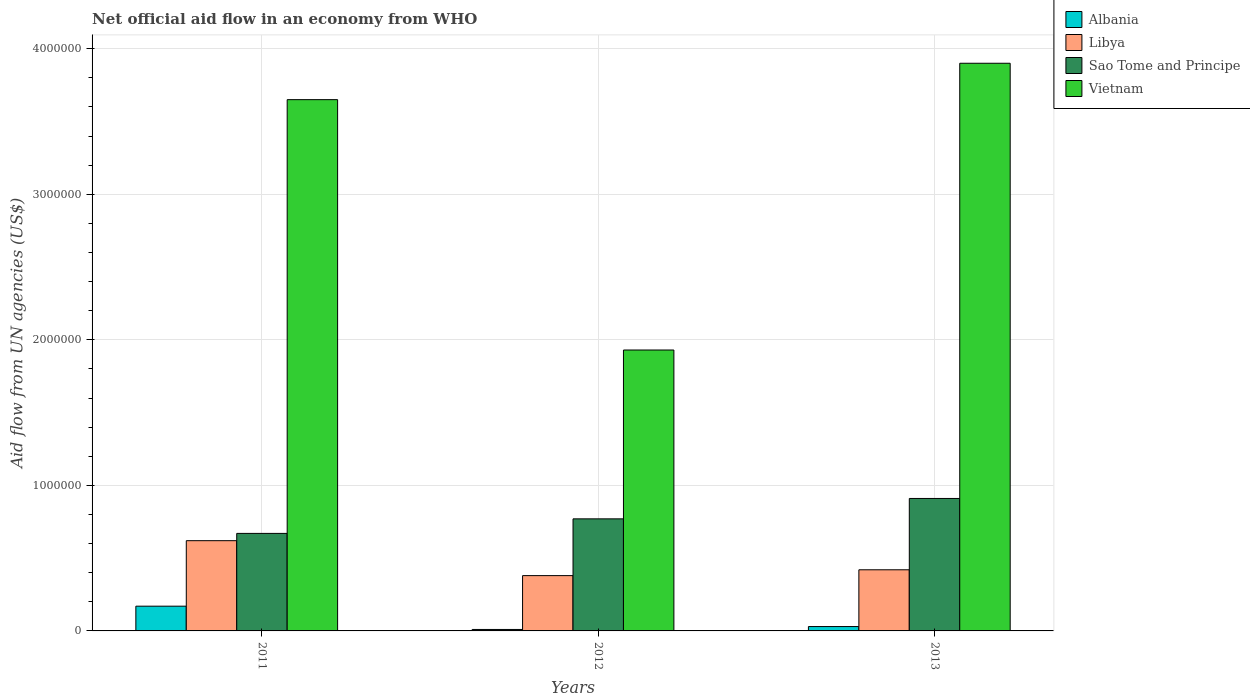Are the number of bars per tick equal to the number of legend labels?
Offer a very short reply. Yes. Are the number of bars on each tick of the X-axis equal?
Provide a succinct answer. Yes. What is the label of the 3rd group of bars from the left?
Offer a very short reply. 2013. In how many cases, is the number of bars for a given year not equal to the number of legend labels?
Offer a terse response. 0. Across all years, what is the maximum net official aid flow in Vietnam?
Make the answer very short. 3.90e+06. Across all years, what is the minimum net official aid flow in Sao Tome and Principe?
Ensure brevity in your answer.  6.70e+05. What is the total net official aid flow in Vietnam in the graph?
Offer a very short reply. 9.48e+06. What is the difference between the net official aid flow in Albania in 2012 and the net official aid flow in Sao Tome and Principe in 2013?
Provide a succinct answer. -9.00e+05. What is the average net official aid flow in Vietnam per year?
Give a very brief answer. 3.16e+06. In the year 2011, what is the difference between the net official aid flow in Albania and net official aid flow in Sao Tome and Principe?
Provide a short and direct response. -5.00e+05. In how many years, is the net official aid flow in Libya greater than 3800000 US$?
Give a very brief answer. 0. What is the ratio of the net official aid flow in Sao Tome and Principe in 2011 to that in 2013?
Ensure brevity in your answer.  0.74. Is the difference between the net official aid flow in Albania in 2011 and 2013 greater than the difference between the net official aid flow in Sao Tome and Principe in 2011 and 2013?
Give a very brief answer. Yes. What is the difference between the highest and the second highest net official aid flow in Albania?
Your answer should be compact. 1.40e+05. What is the difference between the highest and the lowest net official aid flow in Libya?
Offer a very short reply. 2.40e+05. Is the sum of the net official aid flow in Libya in 2011 and 2013 greater than the maximum net official aid flow in Sao Tome and Principe across all years?
Your answer should be compact. Yes. Is it the case that in every year, the sum of the net official aid flow in Vietnam and net official aid flow in Libya is greater than the sum of net official aid flow in Albania and net official aid flow in Sao Tome and Principe?
Your response must be concise. Yes. What does the 3rd bar from the left in 2012 represents?
Provide a succinct answer. Sao Tome and Principe. What does the 1st bar from the right in 2011 represents?
Keep it short and to the point. Vietnam. Is it the case that in every year, the sum of the net official aid flow in Albania and net official aid flow in Sao Tome and Principe is greater than the net official aid flow in Vietnam?
Provide a succinct answer. No. How many bars are there?
Your answer should be very brief. 12. How many years are there in the graph?
Ensure brevity in your answer.  3. Are the values on the major ticks of Y-axis written in scientific E-notation?
Keep it short and to the point. No. Does the graph contain any zero values?
Offer a terse response. No. How many legend labels are there?
Offer a very short reply. 4. What is the title of the graph?
Provide a short and direct response. Net official aid flow in an economy from WHO. What is the label or title of the X-axis?
Provide a succinct answer. Years. What is the label or title of the Y-axis?
Provide a succinct answer. Aid flow from UN agencies (US$). What is the Aid flow from UN agencies (US$) of Libya in 2011?
Your response must be concise. 6.20e+05. What is the Aid flow from UN agencies (US$) in Sao Tome and Principe in 2011?
Ensure brevity in your answer.  6.70e+05. What is the Aid flow from UN agencies (US$) in Vietnam in 2011?
Keep it short and to the point. 3.65e+06. What is the Aid flow from UN agencies (US$) in Albania in 2012?
Keep it short and to the point. 10000. What is the Aid flow from UN agencies (US$) in Sao Tome and Principe in 2012?
Your response must be concise. 7.70e+05. What is the Aid flow from UN agencies (US$) of Vietnam in 2012?
Give a very brief answer. 1.93e+06. What is the Aid flow from UN agencies (US$) of Albania in 2013?
Give a very brief answer. 3.00e+04. What is the Aid flow from UN agencies (US$) in Sao Tome and Principe in 2013?
Give a very brief answer. 9.10e+05. What is the Aid flow from UN agencies (US$) of Vietnam in 2013?
Provide a succinct answer. 3.90e+06. Across all years, what is the maximum Aid flow from UN agencies (US$) in Libya?
Your answer should be very brief. 6.20e+05. Across all years, what is the maximum Aid flow from UN agencies (US$) in Sao Tome and Principe?
Provide a succinct answer. 9.10e+05. Across all years, what is the maximum Aid flow from UN agencies (US$) of Vietnam?
Make the answer very short. 3.90e+06. Across all years, what is the minimum Aid flow from UN agencies (US$) in Libya?
Keep it short and to the point. 3.80e+05. Across all years, what is the minimum Aid flow from UN agencies (US$) in Sao Tome and Principe?
Provide a short and direct response. 6.70e+05. Across all years, what is the minimum Aid flow from UN agencies (US$) in Vietnam?
Your response must be concise. 1.93e+06. What is the total Aid flow from UN agencies (US$) of Libya in the graph?
Give a very brief answer. 1.42e+06. What is the total Aid flow from UN agencies (US$) of Sao Tome and Principe in the graph?
Your response must be concise. 2.35e+06. What is the total Aid flow from UN agencies (US$) in Vietnam in the graph?
Offer a terse response. 9.48e+06. What is the difference between the Aid flow from UN agencies (US$) in Vietnam in 2011 and that in 2012?
Ensure brevity in your answer.  1.72e+06. What is the difference between the Aid flow from UN agencies (US$) of Libya in 2011 and that in 2013?
Ensure brevity in your answer.  2.00e+05. What is the difference between the Aid flow from UN agencies (US$) of Vietnam in 2011 and that in 2013?
Give a very brief answer. -2.50e+05. What is the difference between the Aid flow from UN agencies (US$) in Vietnam in 2012 and that in 2013?
Your answer should be compact. -1.97e+06. What is the difference between the Aid flow from UN agencies (US$) of Albania in 2011 and the Aid flow from UN agencies (US$) of Libya in 2012?
Ensure brevity in your answer.  -2.10e+05. What is the difference between the Aid flow from UN agencies (US$) in Albania in 2011 and the Aid flow from UN agencies (US$) in Sao Tome and Principe in 2012?
Provide a short and direct response. -6.00e+05. What is the difference between the Aid flow from UN agencies (US$) in Albania in 2011 and the Aid flow from UN agencies (US$) in Vietnam in 2012?
Ensure brevity in your answer.  -1.76e+06. What is the difference between the Aid flow from UN agencies (US$) of Libya in 2011 and the Aid flow from UN agencies (US$) of Vietnam in 2012?
Offer a very short reply. -1.31e+06. What is the difference between the Aid flow from UN agencies (US$) in Sao Tome and Principe in 2011 and the Aid flow from UN agencies (US$) in Vietnam in 2012?
Provide a short and direct response. -1.26e+06. What is the difference between the Aid flow from UN agencies (US$) of Albania in 2011 and the Aid flow from UN agencies (US$) of Sao Tome and Principe in 2013?
Provide a short and direct response. -7.40e+05. What is the difference between the Aid flow from UN agencies (US$) of Albania in 2011 and the Aid flow from UN agencies (US$) of Vietnam in 2013?
Ensure brevity in your answer.  -3.73e+06. What is the difference between the Aid flow from UN agencies (US$) in Libya in 2011 and the Aid flow from UN agencies (US$) in Sao Tome and Principe in 2013?
Offer a terse response. -2.90e+05. What is the difference between the Aid flow from UN agencies (US$) in Libya in 2011 and the Aid flow from UN agencies (US$) in Vietnam in 2013?
Your answer should be compact. -3.28e+06. What is the difference between the Aid flow from UN agencies (US$) in Sao Tome and Principe in 2011 and the Aid flow from UN agencies (US$) in Vietnam in 2013?
Your answer should be compact. -3.23e+06. What is the difference between the Aid flow from UN agencies (US$) of Albania in 2012 and the Aid flow from UN agencies (US$) of Libya in 2013?
Give a very brief answer. -4.10e+05. What is the difference between the Aid flow from UN agencies (US$) of Albania in 2012 and the Aid flow from UN agencies (US$) of Sao Tome and Principe in 2013?
Offer a very short reply. -9.00e+05. What is the difference between the Aid flow from UN agencies (US$) of Albania in 2012 and the Aid flow from UN agencies (US$) of Vietnam in 2013?
Make the answer very short. -3.89e+06. What is the difference between the Aid flow from UN agencies (US$) of Libya in 2012 and the Aid flow from UN agencies (US$) of Sao Tome and Principe in 2013?
Provide a short and direct response. -5.30e+05. What is the difference between the Aid flow from UN agencies (US$) of Libya in 2012 and the Aid flow from UN agencies (US$) of Vietnam in 2013?
Provide a succinct answer. -3.52e+06. What is the difference between the Aid flow from UN agencies (US$) of Sao Tome and Principe in 2012 and the Aid flow from UN agencies (US$) of Vietnam in 2013?
Your answer should be very brief. -3.13e+06. What is the average Aid flow from UN agencies (US$) of Albania per year?
Provide a short and direct response. 7.00e+04. What is the average Aid flow from UN agencies (US$) in Libya per year?
Your answer should be compact. 4.73e+05. What is the average Aid flow from UN agencies (US$) in Sao Tome and Principe per year?
Your answer should be very brief. 7.83e+05. What is the average Aid flow from UN agencies (US$) of Vietnam per year?
Offer a very short reply. 3.16e+06. In the year 2011, what is the difference between the Aid flow from UN agencies (US$) of Albania and Aid flow from UN agencies (US$) of Libya?
Your response must be concise. -4.50e+05. In the year 2011, what is the difference between the Aid flow from UN agencies (US$) of Albania and Aid flow from UN agencies (US$) of Sao Tome and Principe?
Your response must be concise. -5.00e+05. In the year 2011, what is the difference between the Aid flow from UN agencies (US$) of Albania and Aid flow from UN agencies (US$) of Vietnam?
Provide a succinct answer. -3.48e+06. In the year 2011, what is the difference between the Aid flow from UN agencies (US$) in Libya and Aid flow from UN agencies (US$) in Vietnam?
Give a very brief answer. -3.03e+06. In the year 2011, what is the difference between the Aid flow from UN agencies (US$) of Sao Tome and Principe and Aid flow from UN agencies (US$) of Vietnam?
Provide a succinct answer. -2.98e+06. In the year 2012, what is the difference between the Aid flow from UN agencies (US$) in Albania and Aid flow from UN agencies (US$) in Libya?
Make the answer very short. -3.70e+05. In the year 2012, what is the difference between the Aid flow from UN agencies (US$) in Albania and Aid flow from UN agencies (US$) in Sao Tome and Principe?
Your response must be concise. -7.60e+05. In the year 2012, what is the difference between the Aid flow from UN agencies (US$) of Albania and Aid flow from UN agencies (US$) of Vietnam?
Give a very brief answer. -1.92e+06. In the year 2012, what is the difference between the Aid flow from UN agencies (US$) in Libya and Aid flow from UN agencies (US$) in Sao Tome and Principe?
Ensure brevity in your answer.  -3.90e+05. In the year 2012, what is the difference between the Aid flow from UN agencies (US$) of Libya and Aid flow from UN agencies (US$) of Vietnam?
Offer a very short reply. -1.55e+06. In the year 2012, what is the difference between the Aid flow from UN agencies (US$) in Sao Tome and Principe and Aid flow from UN agencies (US$) in Vietnam?
Provide a short and direct response. -1.16e+06. In the year 2013, what is the difference between the Aid flow from UN agencies (US$) of Albania and Aid flow from UN agencies (US$) of Libya?
Keep it short and to the point. -3.90e+05. In the year 2013, what is the difference between the Aid flow from UN agencies (US$) of Albania and Aid flow from UN agencies (US$) of Sao Tome and Principe?
Ensure brevity in your answer.  -8.80e+05. In the year 2013, what is the difference between the Aid flow from UN agencies (US$) of Albania and Aid flow from UN agencies (US$) of Vietnam?
Offer a terse response. -3.87e+06. In the year 2013, what is the difference between the Aid flow from UN agencies (US$) in Libya and Aid flow from UN agencies (US$) in Sao Tome and Principe?
Give a very brief answer. -4.90e+05. In the year 2013, what is the difference between the Aid flow from UN agencies (US$) of Libya and Aid flow from UN agencies (US$) of Vietnam?
Offer a very short reply. -3.48e+06. In the year 2013, what is the difference between the Aid flow from UN agencies (US$) in Sao Tome and Principe and Aid flow from UN agencies (US$) in Vietnam?
Ensure brevity in your answer.  -2.99e+06. What is the ratio of the Aid flow from UN agencies (US$) of Libya in 2011 to that in 2012?
Make the answer very short. 1.63. What is the ratio of the Aid flow from UN agencies (US$) of Sao Tome and Principe in 2011 to that in 2012?
Give a very brief answer. 0.87. What is the ratio of the Aid flow from UN agencies (US$) of Vietnam in 2011 to that in 2012?
Keep it short and to the point. 1.89. What is the ratio of the Aid flow from UN agencies (US$) of Albania in 2011 to that in 2013?
Provide a succinct answer. 5.67. What is the ratio of the Aid flow from UN agencies (US$) in Libya in 2011 to that in 2013?
Provide a succinct answer. 1.48. What is the ratio of the Aid flow from UN agencies (US$) of Sao Tome and Principe in 2011 to that in 2013?
Give a very brief answer. 0.74. What is the ratio of the Aid flow from UN agencies (US$) of Vietnam in 2011 to that in 2013?
Ensure brevity in your answer.  0.94. What is the ratio of the Aid flow from UN agencies (US$) in Libya in 2012 to that in 2013?
Your answer should be compact. 0.9. What is the ratio of the Aid flow from UN agencies (US$) of Sao Tome and Principe in 2012 to that in 2013?
Your answer should be very brief. 0.85. What is the ratio of the Aid flow from UN agencies (US$) of Vietnam in 2012 to that in 2013?
Offer a terse response. 0.49. What is the difference between the highest and the lowest Aid flow from UN agencies (US$) in Albania?
Give a very brief answer. 1.60e+05. What is the difference between the highest and the lowest Aid flow from UN agencies (US$) in Libya?
Provide a succinct answer. 2.40e+05. What is the difference between the highest and the lowest Aid flow from UN agencies (US$) of Sao Tome and Principe?
Provide a short and direct response. 2.40e+05. What is the difference between the highest and the lowest Aid flow from UN agencies (US$) in Vietnam?
Your answer should be compact. 1.97e+06. 